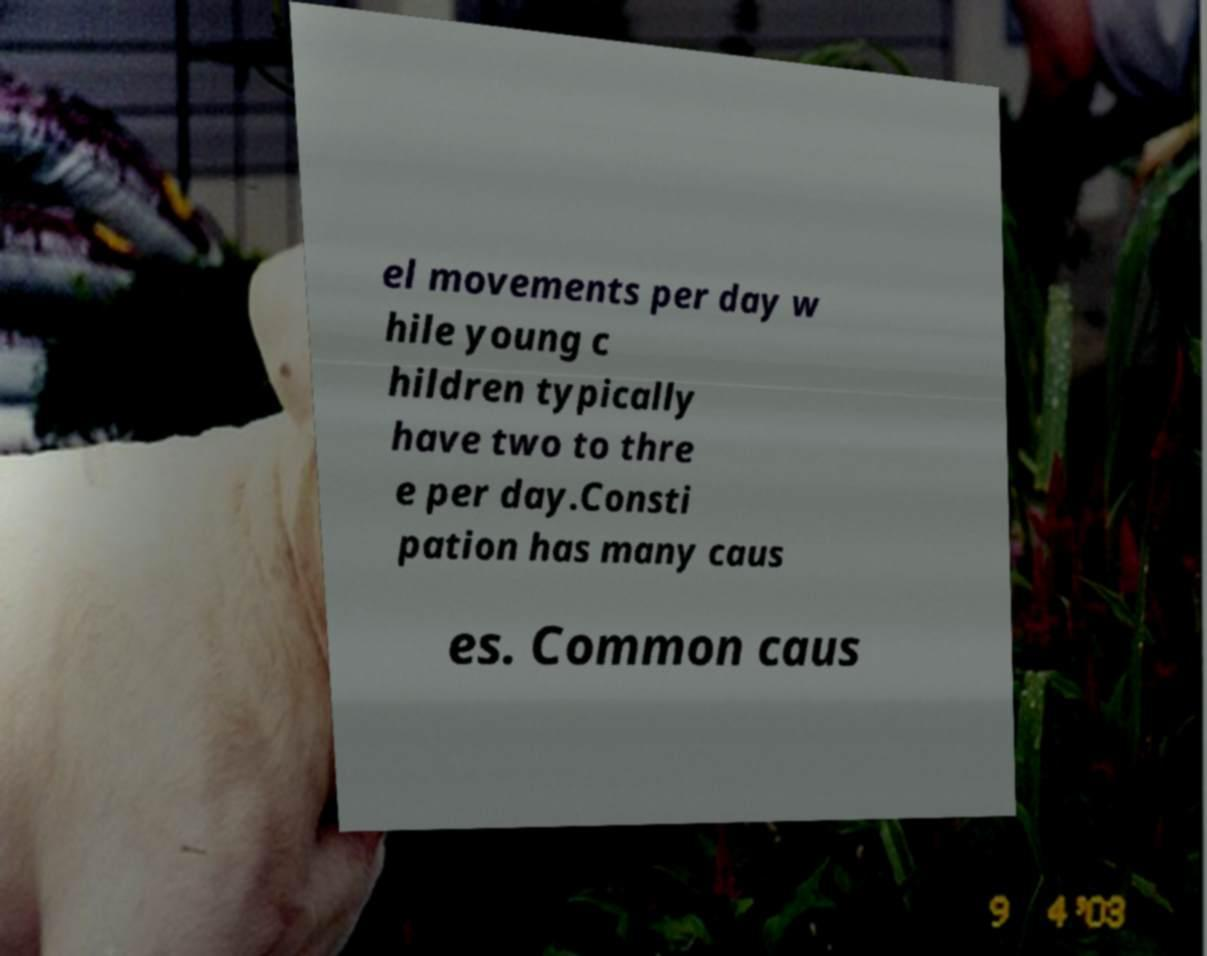Please read and relay the text visible in this image. What does it say? el movements per day w hile young c hildren typically have two to thre e per day.Consti pation has many caus es. Common caus 